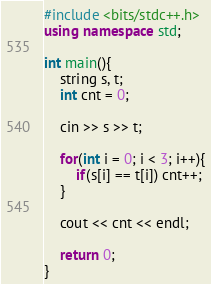<code> <loc_0><loc_0><loc_500><loc_500><_C++_>#include <bits/stdc++.h>
using namespace std;

int main(){
    string s, t;
    int cnt = 0;

    cin >> s >> t;

    for(int i = 0; i < 3; i++){
        if(s[i] == t[i]) cnt++;
    }

    cout << cnt << endl;
    
    return 0;
}
</code> 